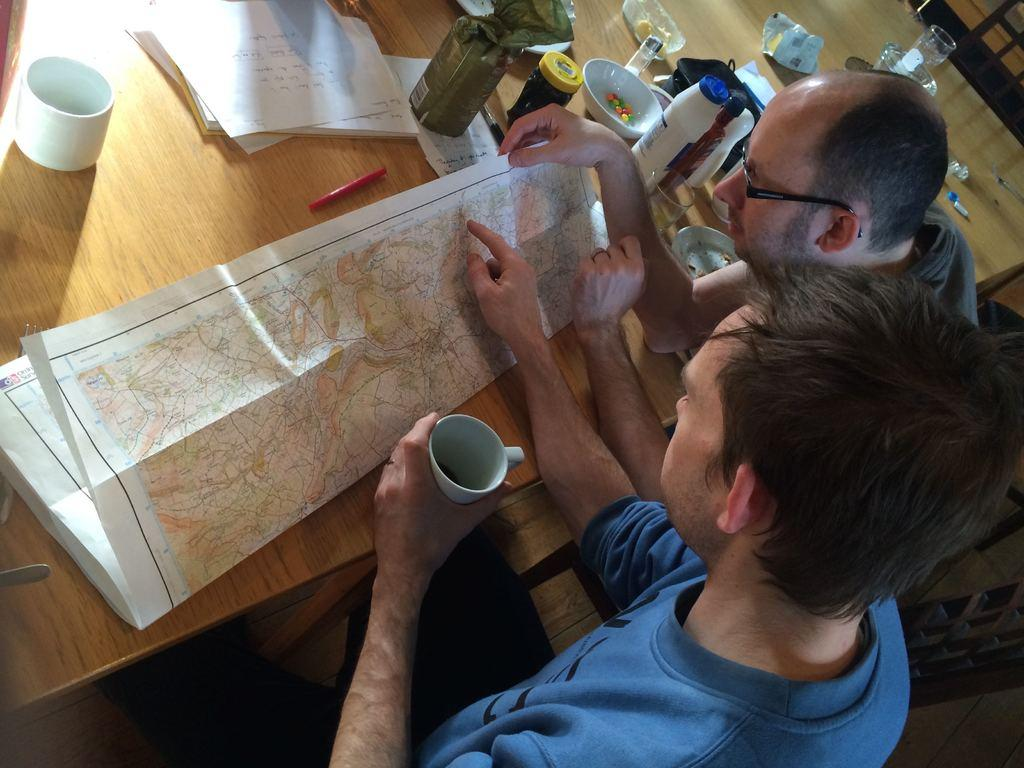How many people are in the image? There are two people in the image. What are the people holding? Both people are holding cups. What is on the table in the image? There are papers, a cup, bottles, a bowl, and a pen on the table. What type of waste is visible in the image? There is no waste visible in the image. What type of breakfast is being served in the image? There is no breakfast being served in the image. 